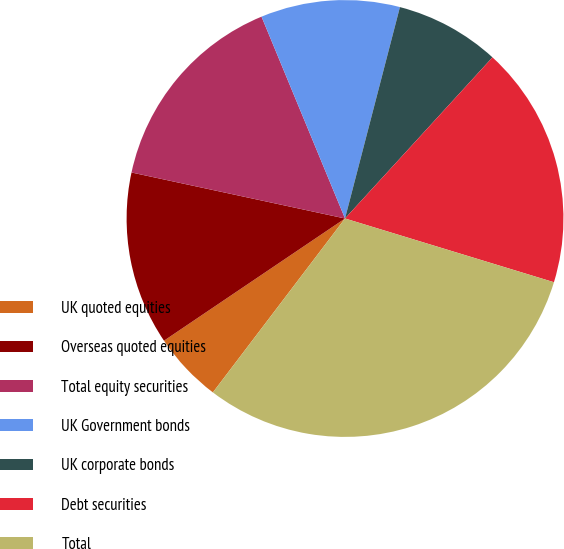Convert chart to OTSL. <chart><loc_0><loc_0><loc_500><loc_500><pie_chart><fcel>UK quoted equities<fcel>Overseas quoted equities<fcel>Total equity securities<fcel>UK Government bonds<fcel>UK corporate bonds<fcel>Debt securities<fcel>Total<nl><fcel>5.21%<fcel>12.83%<fcel>15.38%<fcel>10.29%<fcel>7.75%<fcel>17.92%<fcel>30.63%<nl></chart> 